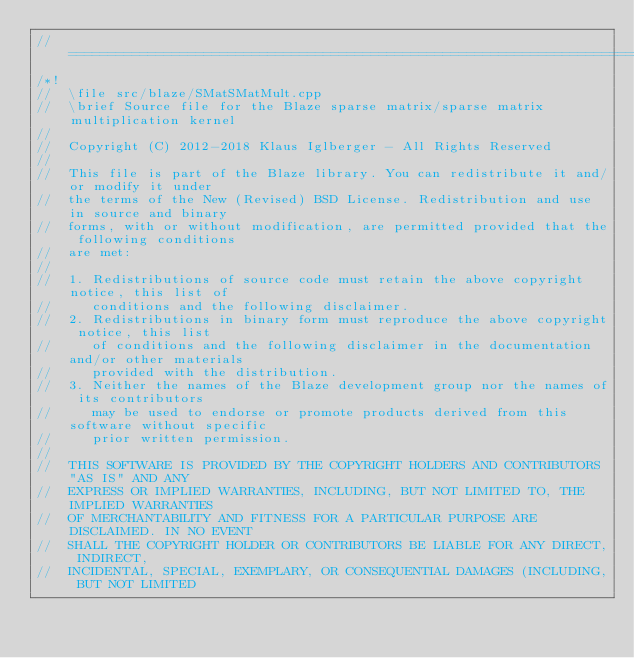Convert code to text. <code><loc_0><loc_0><loc_500><loc_500><_C++_>//=================================================================================================
/*!
//  \file src/blaze/SMatSMatMult.cpp
//  \brief Source file for the Blaze sparse matrix/sparse matrix multiplication kernel
//
//  Copyright (C) 2012-2018 Klaus Iglberger - All Rights Reserved
//
//  This file is part of the Blaze library. You can redistribute it and/or modify it under
//  the terms of the New (Revised) BSD License. Redistribution and use in source and binary
//  forms, with or without modification, are permitted provided that the following conditions
//  are met:
//
//  1. Redistributions of source code must retain the above copyright notice, this list of
//     conditions and the following disclaimer.
//  2. Redistributions in binary form must reproduce the above copyright notice, this list
//     of conditions and the following disclaimer in the documentation and/or other materials
//     provided with the distribution.
//  3. Neither the names of the Blaze development group nor the names of its contributors
//     may be used to endorse or promote products derived from this software without specific
//     prior written permission.
//
//  THIS SOFTWARE IS PROVIDED BY THE COPYRIGHT HOLDERS AND CONTRIBUTORS "AS IS" AND ANY
//  EXPRESS OR IMPLIED WARRANTIES, INCLUDING, BUT NOT LIMITED TO, THE IMPLIED WARRANTIES
//  OF MERCHANTABILITY AND FITNESS FOR A PARTICULAR PURPOSE ARE DISCLAIMED. IN NO EVENT
//  SHALL THE COPYRIGHT HOLDER OR CONTRIBUTORS BE LIABLE FOR ANY DIRECT, INDIRECT,
//  INCIDENTAL, SPECIAL, EXEMPLARY, OR CONSEQUENTIAL DAMAGES (INCLUDING, BUT NOT LIMITED</code> 